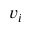Convert formula to latex. <formula><loc_0><loc_0><loc_500><loc_500>v _ { i }</formula> 